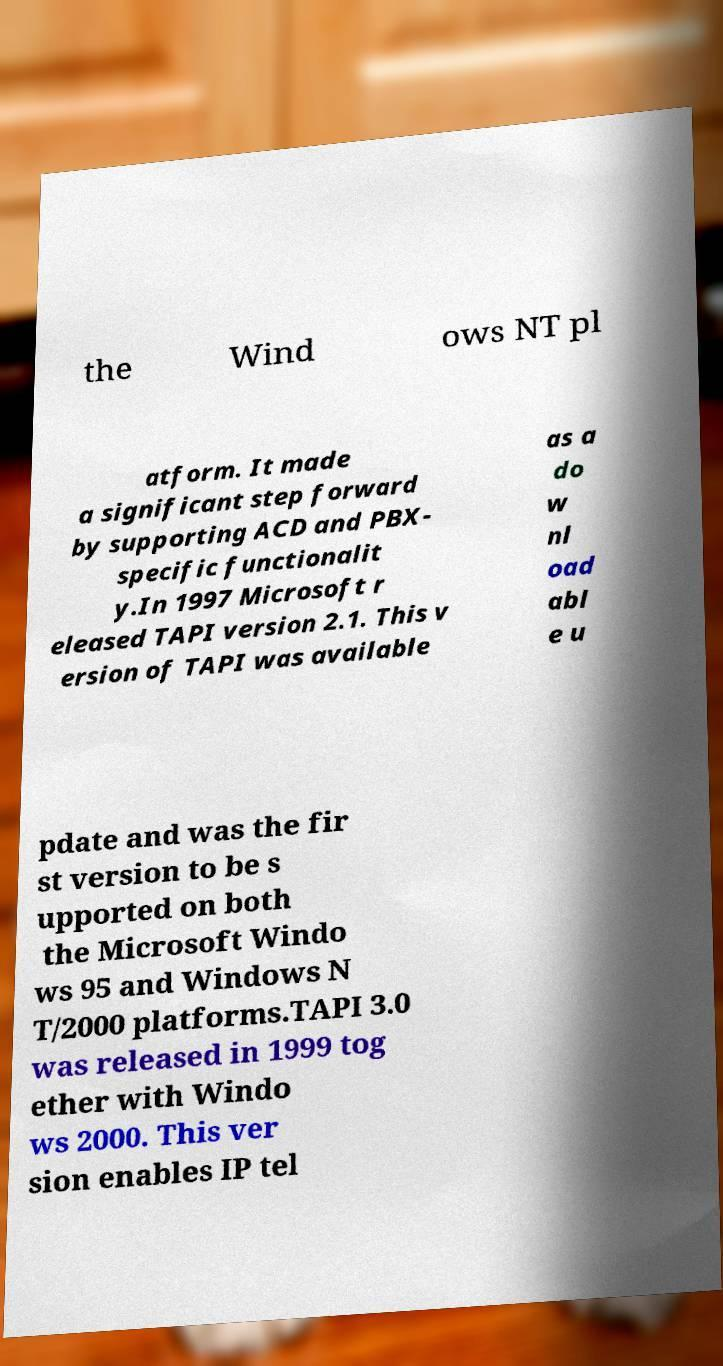Could you extract and type out the text from this image? the Wind ows NT pl atform. It made a significant step forward by supporting ACD and PBX- specific functionalit y.In 1997 Microsoft r eleased TAPI version 2.1. This v ersion of TAPI was available as a do w nl oad abl e u pdate and was the fir st version to be s upported on both the Microsoft Windo ws 95 and Windows N T/2000 platforms.TAPI 3.0 was released in 1999 tog ether with Windo ws 2000. This ver sion enables IP tel 